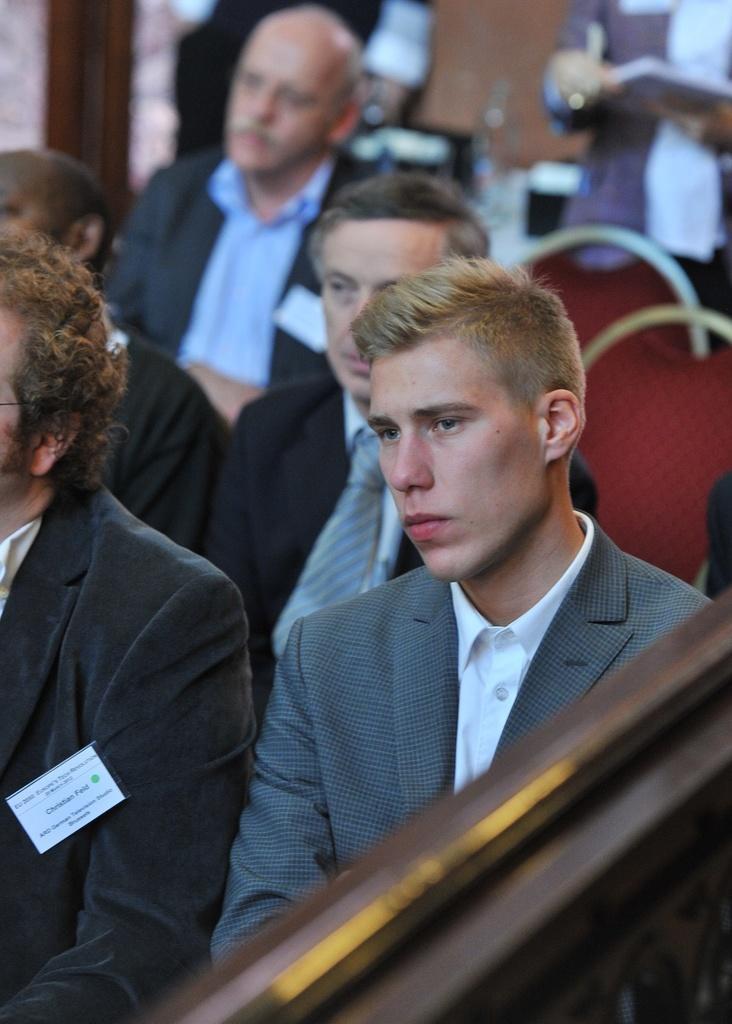Could you give a brief overview of what you see in this image? This picture is clicked inside. In the foreground we can see the group of persons wearing suits and sitting on the chairs. In the background we can see the red color chairs and some persons standing on the ground and there are some objects. 